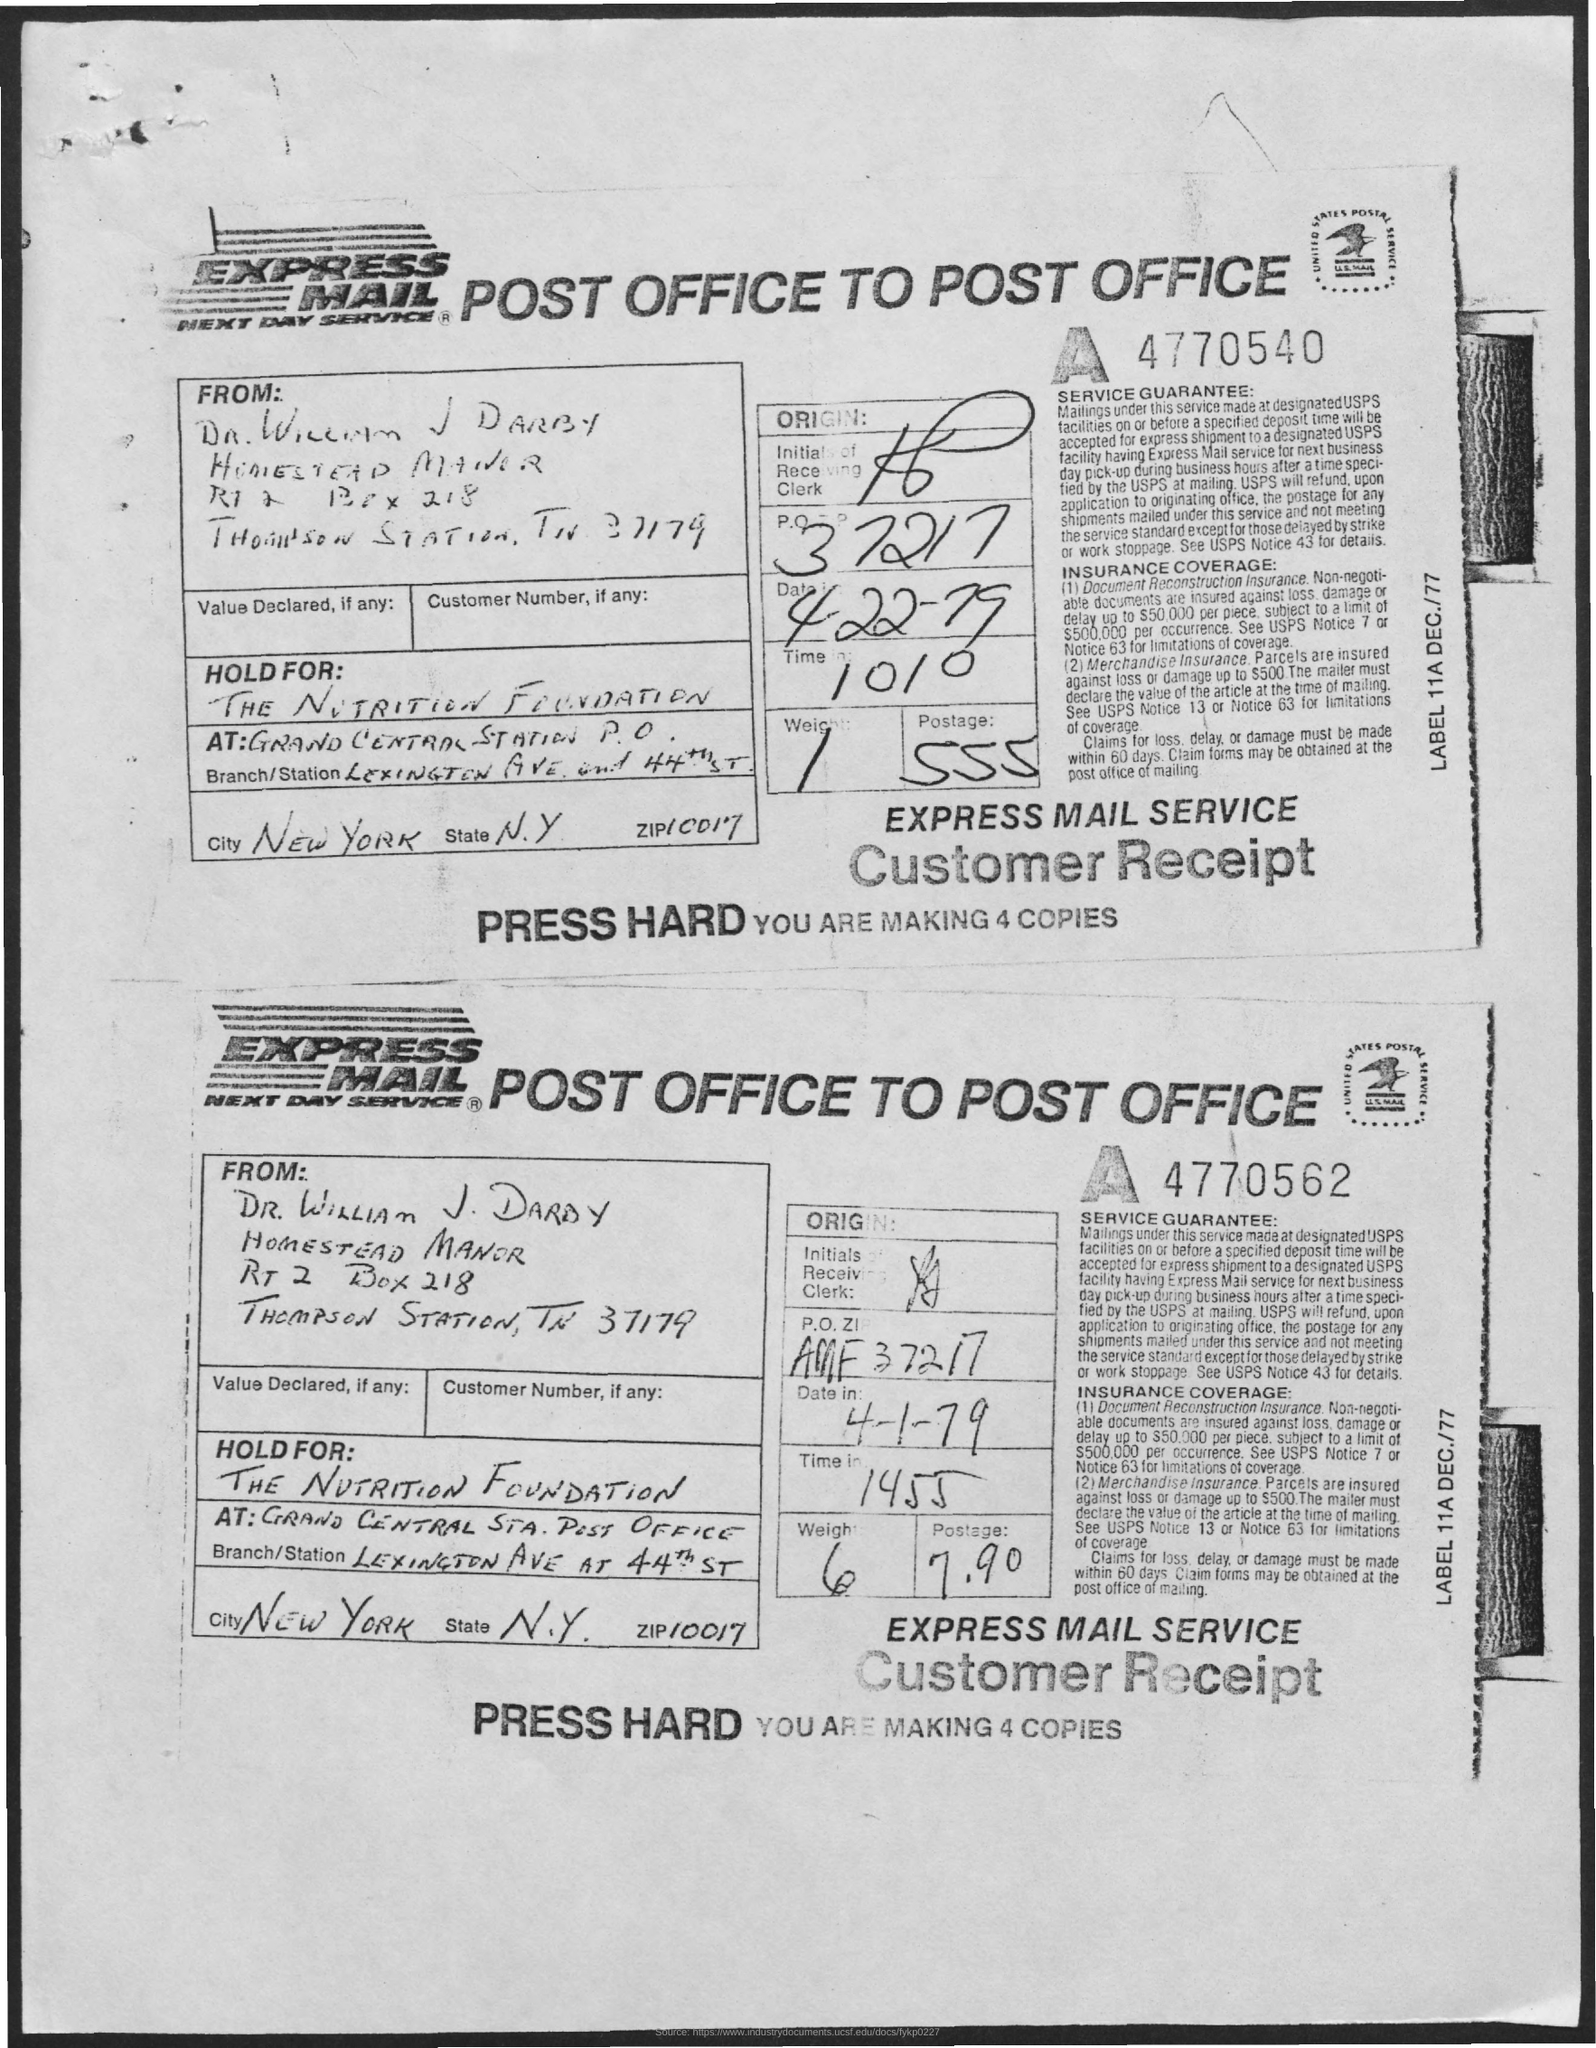What is the name of the city?
Your answer should be compact. New York. What is the name of the state?
Provide a short and direct response. N.Y. What is the ZIP code?
Your response must be concise. 10017. What is the PO Box Number mentioned in the document?
Provide a succinct answer. 218. 